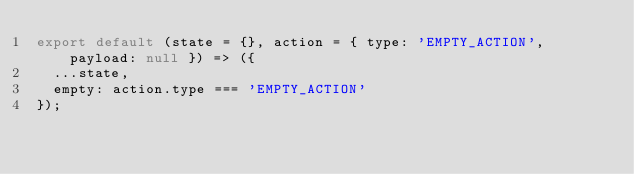Convert code to text. <code><loc_0><loc_0><loc_500><loc_500><_JavaScript_>export default (state = {}, action = { type: 'EMPTY_ACTION', payload: null }) => ({
  ...state,
  empty: action.type === 'EMPTY_ACTION'
});
</code> 